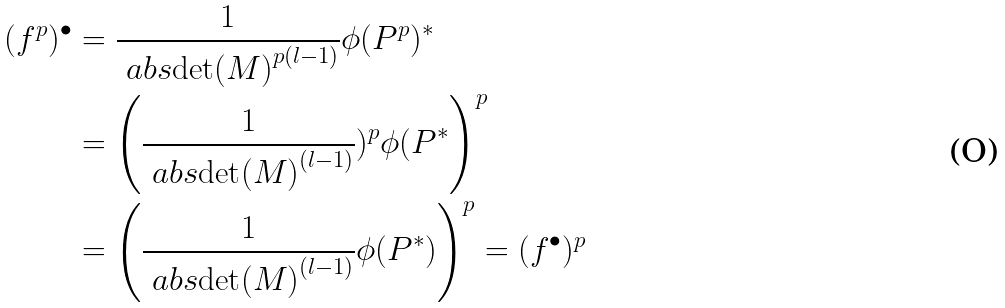Convert formula to latex. <formula><loc_0><loc_0><loc_500><loc_500>( f ^ { p } ) ^ { \bullet } & = \frac { 1 } { \ a b s { \det ( M ) } ^ { p ( l - 1 ) } } \phi ( P ^ { p } ) ^ { * } \\ & = \left ( \frac { 1 } { \ a b s { \det ( M ) } ^ { ( l - 1 ) } } ) ^ { p } \phi ( P ^ { * } \right ) ^ { p } \\ & = \left ( \frac { 1 } { \ a b s { \det ( M ) } ^ { ( l - 1 ) } } \phi ( P ^ { * } ) \right ) ^ { p } = ( f ^ { \bullet } ) ^ { p }</formula> 